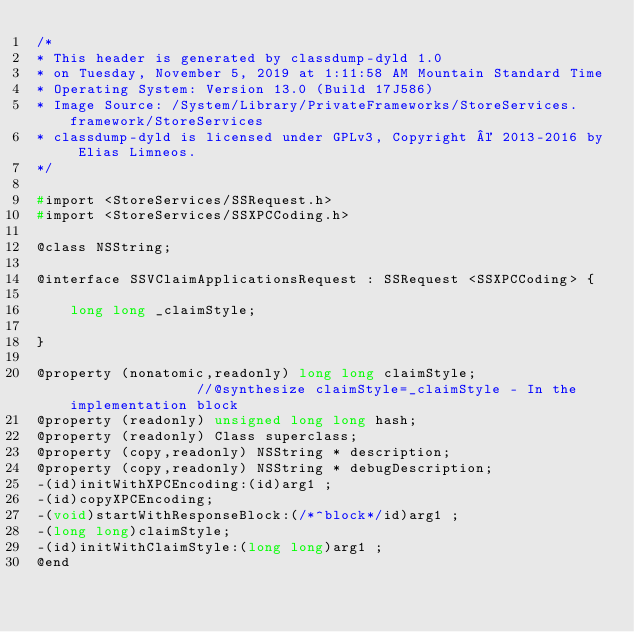Convert code to text. <code><loc_0><loc_0><loc_500><loc_500><_C_>/*
* This header is generated by classdump-dyld 1.0
* on Tuesday, November 5, 2019 at 1:11:58 AM Mountain Standard Time
* Operating System: Version 13.0 (Build 17J586)
* Image Source: /System/Library/PrivateFrameworks/StoreServices.framework/StoreServices
* classdump-dyld is licensed under GPLv3, Copyright © 2013-2016 by Elias Limneos.
*/

#import <StoreServices/SSRequest.h>
#import <StoreServices/SSXPCCoding.h>

@class NSString;

@interface SSVClaimApplicationsRequest : SSRequest <SSXPCCoding> {

	long long _claimStyle;

}

@property (nonatomic,readonly) long long claimStyle;                //@synthesize claimStyle=_claimStyle - In the implementation block
@property (readonly) unsigned long long hash; 
@property (readonly) Class superclass; 
@property (copy,readonly) NSString * description; 
@property (copy,readonly) NSString * debugDescription; 
-(id)initWithXPCEncoding:(id)arg1 ;
-(id)copyXPCEncoding;
-(void)startWithResponseBlock:(/*^block*/id)arg1 ;
-(long long)claimStyle;
-(id)initWithClaimStyle:(long long)arg1 ;
@end

</code> 